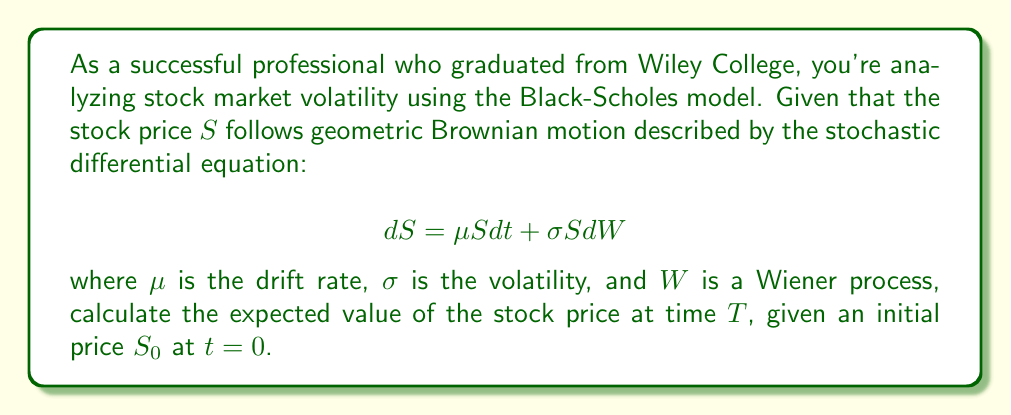Can you answer this question? Let's approach this step-by-step:

1) The Black-Scholes model assumes that the stock price follows geometric Brownian motion, which is described by the given stochastic differential equation.

2) To solve for the expected value of $S$ at time $T$, we need to use Itô's lemma and solve the resulting equation.

3) Let $Y = \ln(S)$. Applying Itô's lemma to $Y$:

   $$dY = \left(\frac{\mu}{S} - \frac{1}{2}\frac{\sigma^2}{S^2}\right)S dt + \frac{\sigma}{S}S dW$$

   $$dY = \left(\mu - \frac{1}{2}\sigma^2\right) dt + \sigma dW$$

4) Integrating both sides from 0 to $T$:

   $$Y_T - Y_0 = \left(\mu - \frac{1}{2}\sigma^2\right)T + \sigma(W_T - W_0)$$

5) Substituting back $Y = \ln(S)$:

   $$\ln(S_T) - \ln(S_0) = \left(\mu - \frac{1}{2}\sigma^2\right)T + \sigma(W_T - W_0)$$

6) Rearranging:

   $$\ln(S_T) = \ln(S_0) + \left(\mu - \frac{1}{2}\sigma^2\right)T + \sigma(W_T - W_0)$$

7) Taking the exponential of both sides:

   $$S_T = S_0 \exp\left(\left(\mu - \frac{1}{2}\sigma^2\right)T + \sigma(W_T - W_0)\right)$$

8) The expected value of $S_T$ is:

   $$E[S_T] = E\left[S_0 \exp\left(\left(\mu - \frac{1}{2}\sigma^2\right)T + \sigma(W_T - W_0)\right)\right]$$

9) Since $W_T - W_0$ follows a normal distribution with mean 0 and variance $T$, we can use the property of lognormal distribution:

   $$E[S_T] = S_0 \exp\left(\left(\mu - \frac{1}{2}\sigma^2\right)T + \frac{1}{2}\sigma^2T\right)$$

10) Simplifying:

    $$E[S_T] = S_0 \exp(\mu T)$$

This is the expected value of the stock price at time $T$.
Answer: $S_0 \exp(\mu T)$ 